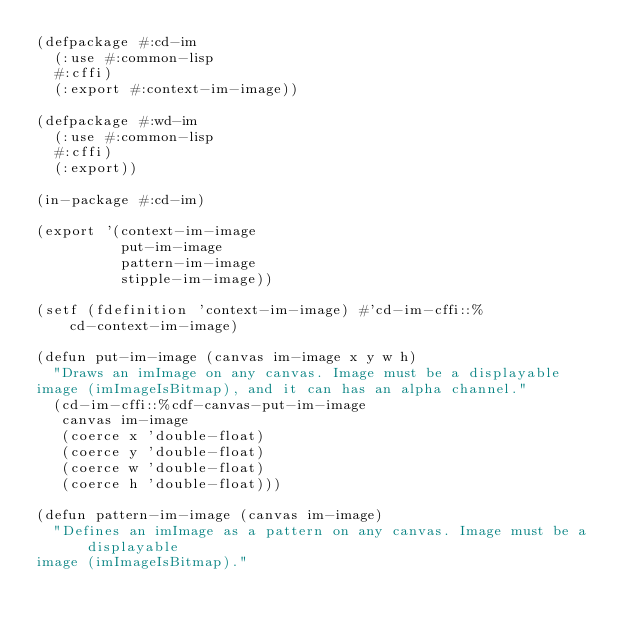Convert code to text. <code><loc_0><loc_0><loc_500><loc_500><_Lisp_>(defpackage #:cd-im
  (:use #:common-lisp
	#:cffi)
  (:export #:context-im-image))

(defpackage #:wd-im
  (:use #:common-lisp
	#:cffi)
  (:export))

(in-package #:cd-im)

(export '(context-im-image
          put-im-image
          pattern-im-image
          stipple-im-image))

(setf (fdefinition 'context-im-image) #'cd-im-cffi::%cd-context-im-image)

(defun put-im-image (canvas im-image x y w h)
  "Draws an imImage on any canvas. Image must be a displayable
image (imImageIsBitmap), and it can has an alpha channel."
  (cd-im-cffi::%cdf-canvas-put-im-image
   canvas im-image
   (coerce x 'double-float)
   (coerce y 'double-float)
   (coerce w 'double-float)
   (coerce h 'double-float)))

(defun pattern-im-image (canvas im-image)
  "Defines an imImage as a pattern on any canvas. Image must be a displayable
image (imImageIsBitmap)."</code> 